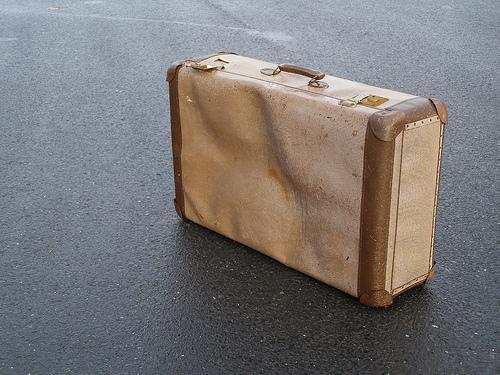How many suitcases are there?
Give a very brief answer. 1. 